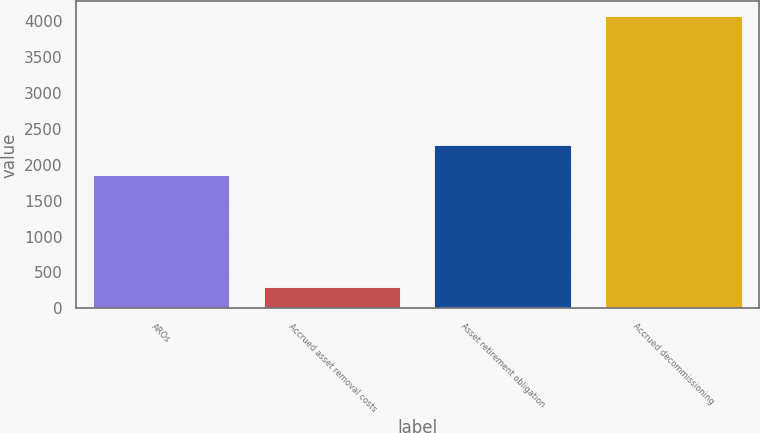Convert chart. <chart><loc_0><loc_0><loc_500><loc_500><bar_chart><fcel>AROs<fcel>Accrued asset removal costs<fcel>Asset retirement obligation<fcel>Accrued decommissioning<nl><fcel>1852<fcel>297<fcel>2272<fcel>4066<nl></chart> 